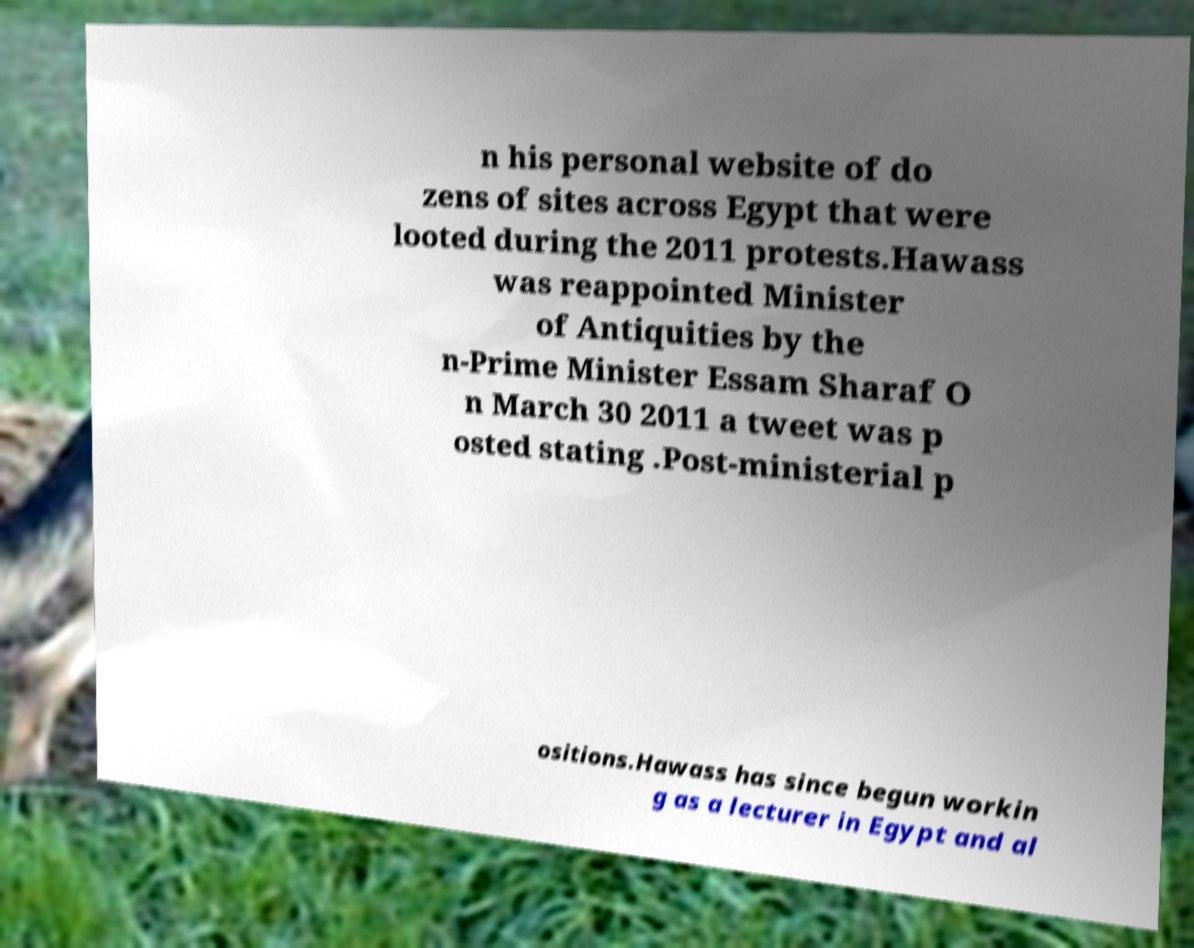Please identify and transcribe the text found in this image. n his personal website of do zens of sites across Egypt that were looted during the 2011 protests.Hawass was reappointed Minister of Antiquities by the n-Prime Minister Essam Sharaf O n March 30 2011 a tweet was p osted stating .Post-ministerial p ositions.Hawass has since begun workin g as a lecturer in Egypt and al 